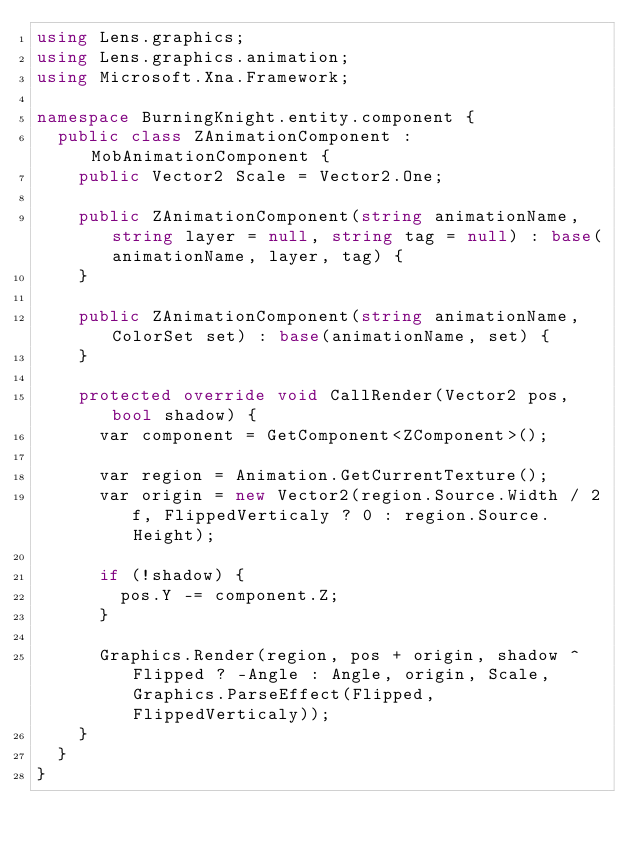Convert code to text. <code><loc_0><loc_0><loc_500><loc_500><_C#_>using Lens.graphics;
using Lens.graphics.animation;
using Microsoft.Xna.Framework;

namespace BurningKnight.entity.component {
	public class ZAnimationComponent : MobAnimationComponent {
		public Vector2 Scale = Vector2.One;
		
		public ZAnimationComponent(string animationName, string layer = null, string tag = null) : base(animationName, layer, tag) {
		}

		public ZAnimationComponent(string animationName, ColorSet set) : base(animationName, set) {
		}

		protected override void CallRender(Vector2 pos, bool shadow) {
			var component = GetComponent<ZComponent>();
			
			var region = Animation.GetCurrentTexture();
			var origin = new Vector2(region.Source.Width / 2f, FlippedVerticaly ? 0 : region.Source.Height);

			if (!shadow) {
				pos.Y -= component.Z;
			}
			
			Graphics.Render(region, pos + origin, shadow ^ Flipped ? -Angle : Angle, origin, Scale, Graphics.ParseEffect(Flipped, FlippedVerticaly));
		}
	}
}</code> 